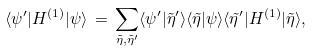Convert formula to latex. <formula><loc_0><loc_0><loc_500><loc_500>\langle \psi ^ { \prime } | H ^ { ( 1 ) } | \psi \rangle \, = \, \sum _ { \tilde { \eta } , \tilde { \eta } ^ { \prime } } \langle \psi ^ { \prime } | \tilde { \eta } ^ { \prime } \rangle \langle \tilde { \eta } | \psi \rangle \langle \tilde { \eta } ^ { \prime } | H ^ { ( 1 ) } | \tilde { \eta } \rangle ,</formula> 